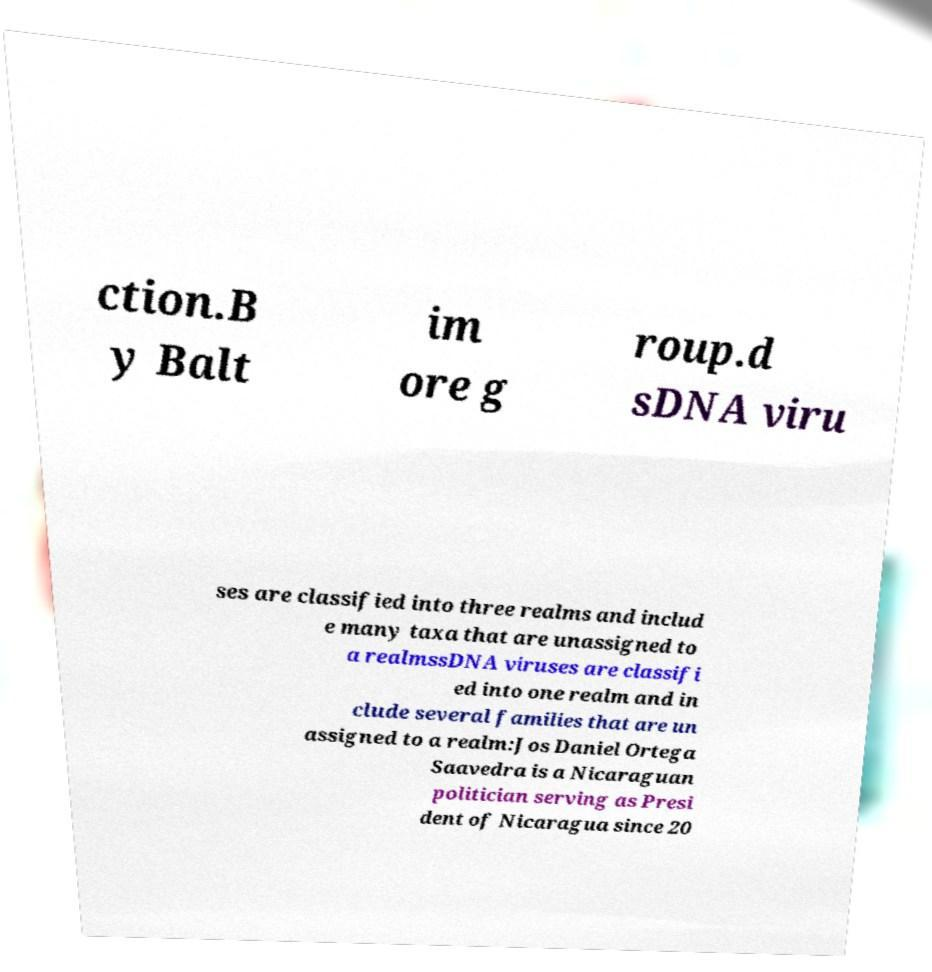Could you extract and type out the text from this image? ction.B y Balt im ore g roup.d sDNA viru ses are classified into three realms and includ e many taxa that are unassigned to a realmssDNA viruses are classifi ed into one realm and in clude several families that are un assigned to a realm:Jos Daniel Ortega Saavedra is a Nicaraguan politician serving as Presi dent of Nicaragua since 20 